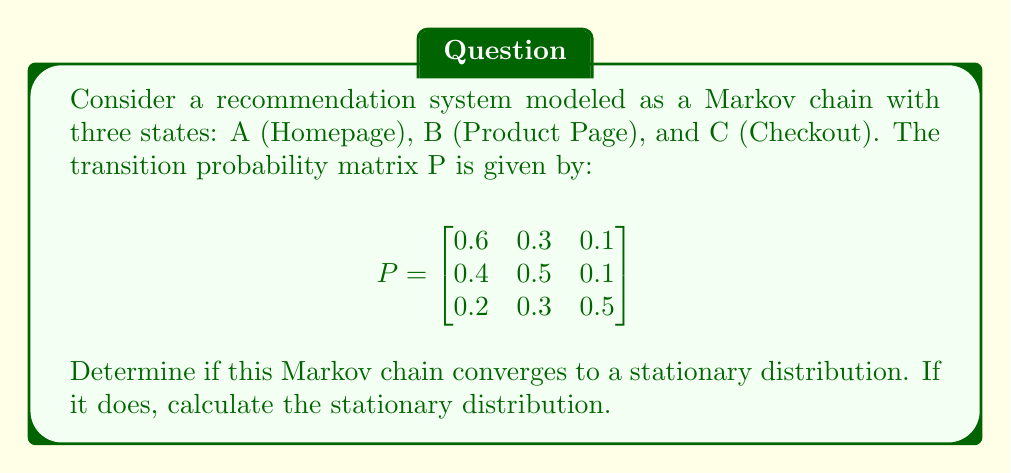Solve this math problem. To analyze the convergence of this Markov chain, we need to follow these steps:

1. Check if the Markov chain is irreducible and aperiodic:
   - Irreducible: All states can be reached from any other state (true in this case).
   - Aperiodic: The greatest common divisor of return times for each state is 1 (true in this case, as self-loops exist).

2. For finite-state irreducible and aperiodic Markov chains, the chain converges to a unique stationary distribution.

3. To find the stationary distribution π, we solve the equation:
   $$\pi P = \pi$$
   $$\pi = [\pi_A, \pi_B, \pi_C]$$

4. This gives us the system of equations:
   $$\begin{cases}
   0.6\pi_A + 0.4\pi_B + 0.2\pi_C = \pi_A \\
   0.3\pi_A + 0.5\pi_B + 0.3\pi_C = \pi_B \\
   0.1\pi_A + 0.1\pi_B + 0.5\pi_C = \pi_C
   \end{cases}$$

5. We also know that $\pi_A + \pi_B + \pi_C = 1$

6. Solving this system of equations:
   $$\begin{cases}
   0.4\pi_A - 0.4\pi_B - 0.2\pi_C = 0 \\
   -0.3\pi_A + 0.5\pi_B - 0.3\pi_C = 0 \\
   \pi_A + \pi_B + \pi_C = 1
   \end{cases}$$

7. Using Gaussian elimination or a matrix solver, we get:
   $$\pi_A \approx 0.4138, \pi_B \approx 0.3793, \pi_C \approx 0.2069$$

Therefore, the Markov chain converges to the stationary distribution [0.4138, 0.3793, 0.2069].
Answer: Yes, converges to [0.4138, 0.3793, 0.2069] 